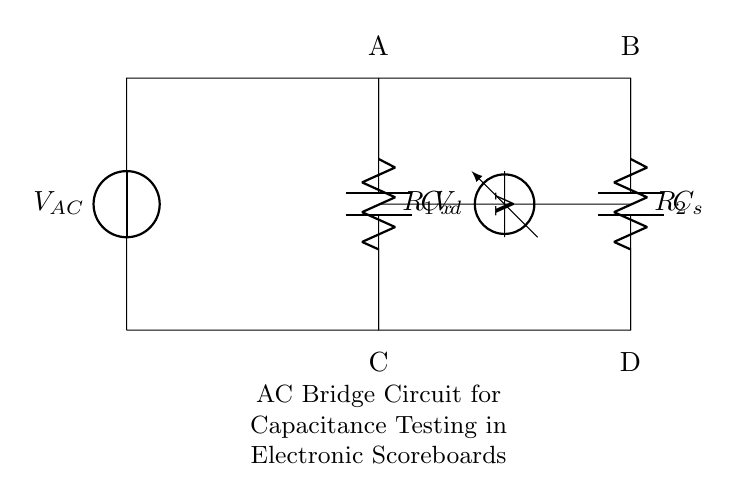What is the type of voltage source in this circuit? The circuit diagram shows a voltage source labeled as \( V_{AC} \), indicating it is an alternating current (AC) voltage source used in the circuit.
Answer: AC What are the two resistors labeled in the diagram? The resistor on the left is labeled \( R_1 \) and the one on the right is labeled \( R_2 \). These components are used in the bridge circuit for balancing.
Answer: \( R_1 \), \( R_2 \) How many capacitors are present in the circuit? The circuit contains two capacitors: \( C_x \) and \( C_s \), which are crucial for measuring capacitance.
Answer: 2 What does \( V_d \) represent in the circuit? \( V_d \) is the voltage measured across the voltmeter, providing information on the voltage difference between points in the circuit.
Answer: Voltage difference How does the bridge condition relate to capacitance testing? The bridge condition is achieved when \( R_1, R_2, C_x, \) and \( C_s \) are in balance, meaning that the ratio of resistances and the capacitances satisfy a specific relationship, resulting in no voltage across \( V_d \).
Answer: No voltage across \( V_d \) What is the overall purpose of this AC bridge circuit? The AC bridge circuit is designed for capacitance testing, particularly useful in electronic scoreboards and displays to determine unknown capacitance values efficiently.
Answer: Capacitance testing 